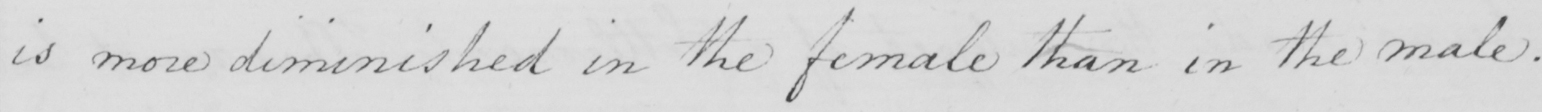Can you read and transcribe this handwriting? is more diminished in the female than in the male . 